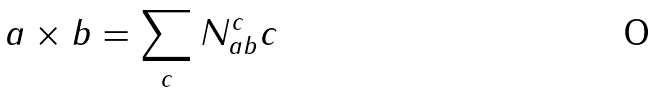Convert formula to latex. <formula><loc_0><loc_0><loc_500><loc_500>a \times b = \sum _ { c } N _ { a b } ^ { c } c</formula> 